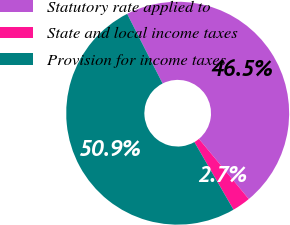Convert chart. <chart><loc_0><loc_0><loc_500><loc_500><pie_chart><fcel>Statutory rate applied to<fcel>State and local income taxes<fcel>Provision for income taxes<nl><fcel>46.48%<fcel>2.66%<fcel>50.86%<nl></chart> 